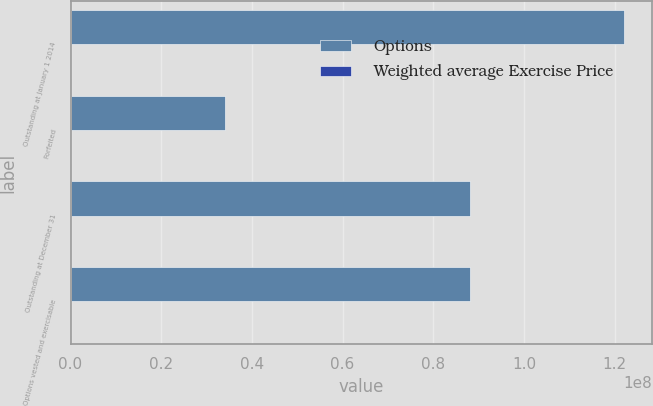<chart> <loc_0><loc_0><loc_500><loc_500><stacked_bar_chart><ecel><fcel>Outstanding at January 1 2014<fcel>Forfeited<fcel>Outstanding at December 31<fcel>Options vested and exercisable<nl><fcel>Options<fcel>1.22169e+08<fcel>3.40816e+07<fcel>8.80871e+07<fcel>8.80871e+07<nl><fcel>Weighted average Exercise Price<fcel>48.23<fcel>46.32<fcel>48.96<fcel>48.96<nl></chart> 